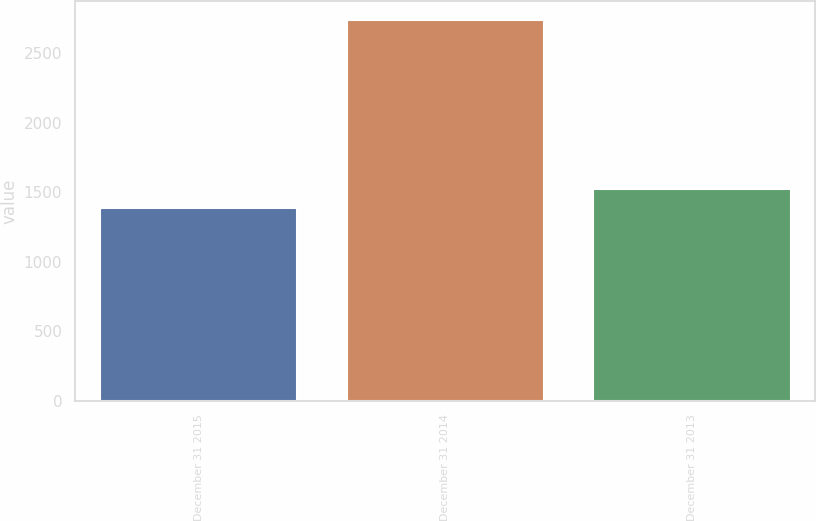<chart> <loc_0><loc_0><loc_500><loc_500><bar_chart><fcel>December 31 2015<fcel>December 31 2014<fcel>December 31 2013<nl><fcel>1387<fcel>2738<fcel>1522.1<nl></chart> 